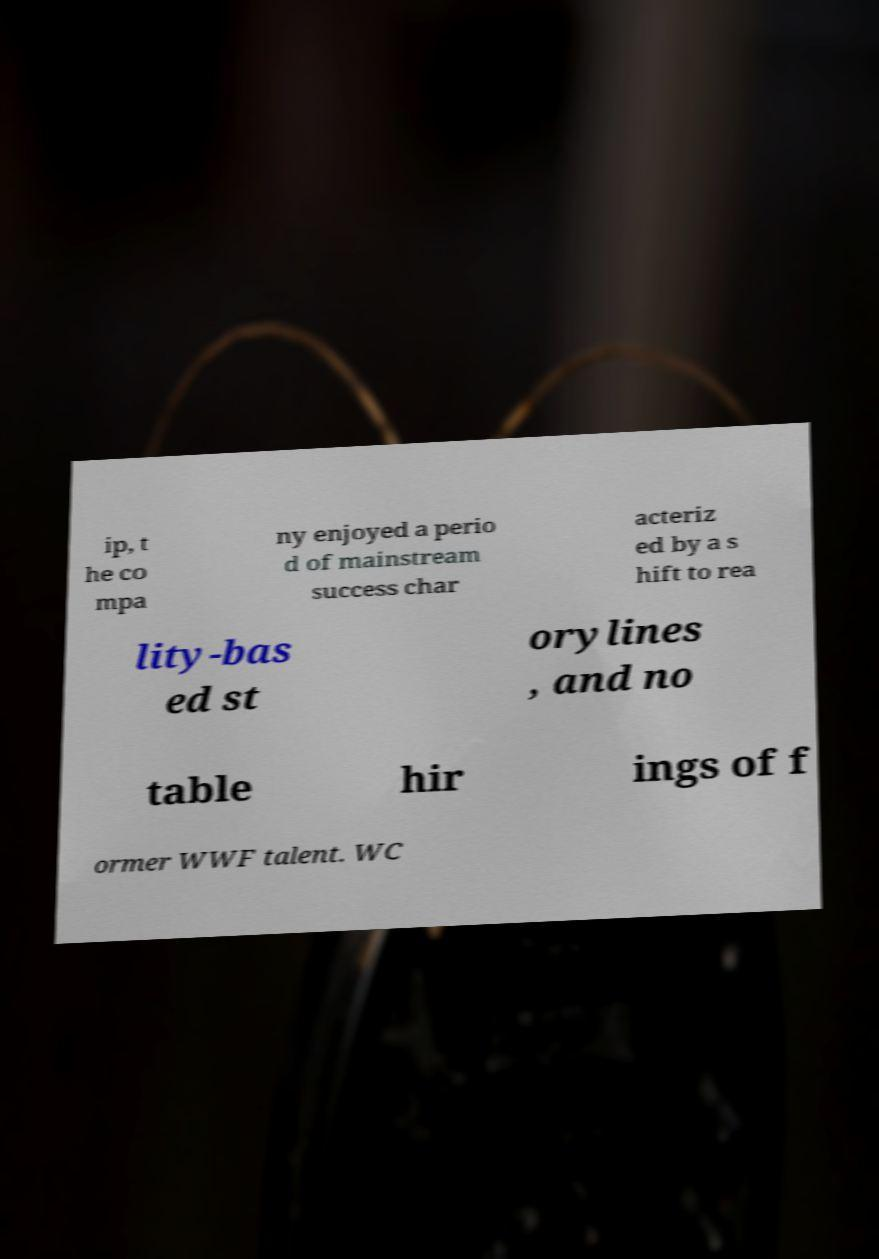There's text embedded in this image that I need extracted. Can you transcribe it verbatim? ip, t he co mpa ny enjoyed a perio d of mainstream success char acteriz ed by a s hift to rea lity-bas ed st orylines , and no table hir ings of f ormer WWF talent. WC 